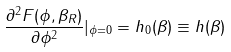<formula> <loc_0><loc_0><loc_500><loc_500>\frac { \partial ^ { 2 } F ( \phi , \beta _ { R } ) } { \partial \phi ^ { 2 } } | _ { \phi = 0 } = h _ { 0 } ( \beta ) \equiv h ( \beta )</formula> 